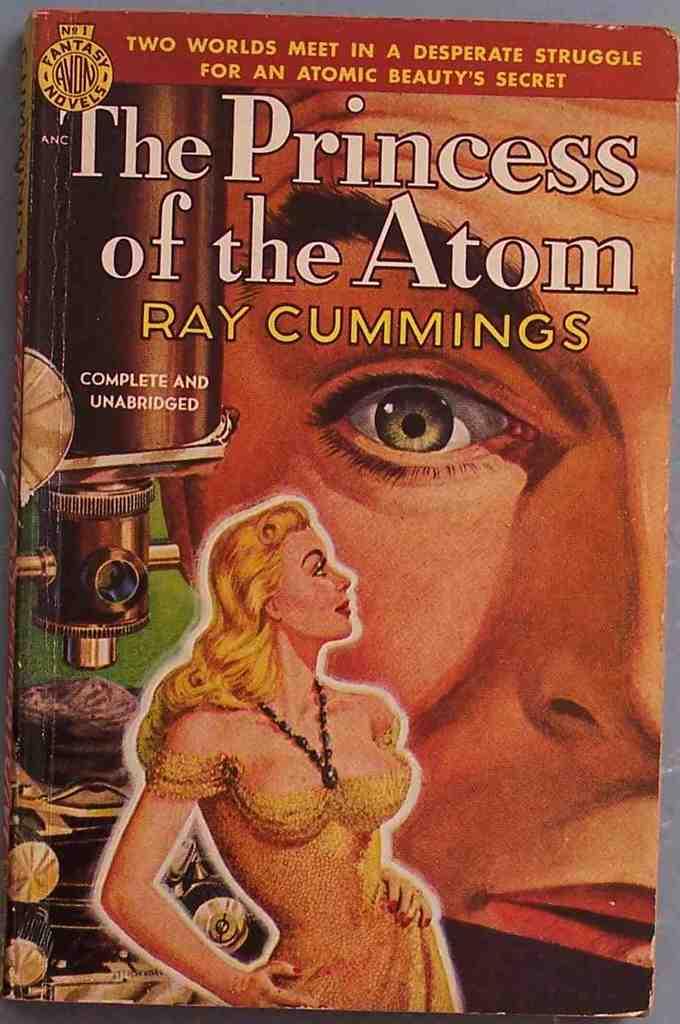Who is the author of this book?
Make the answer very short. Ray cummings. What is the title of the book?
Make the answer very short. The princess of the atom. 